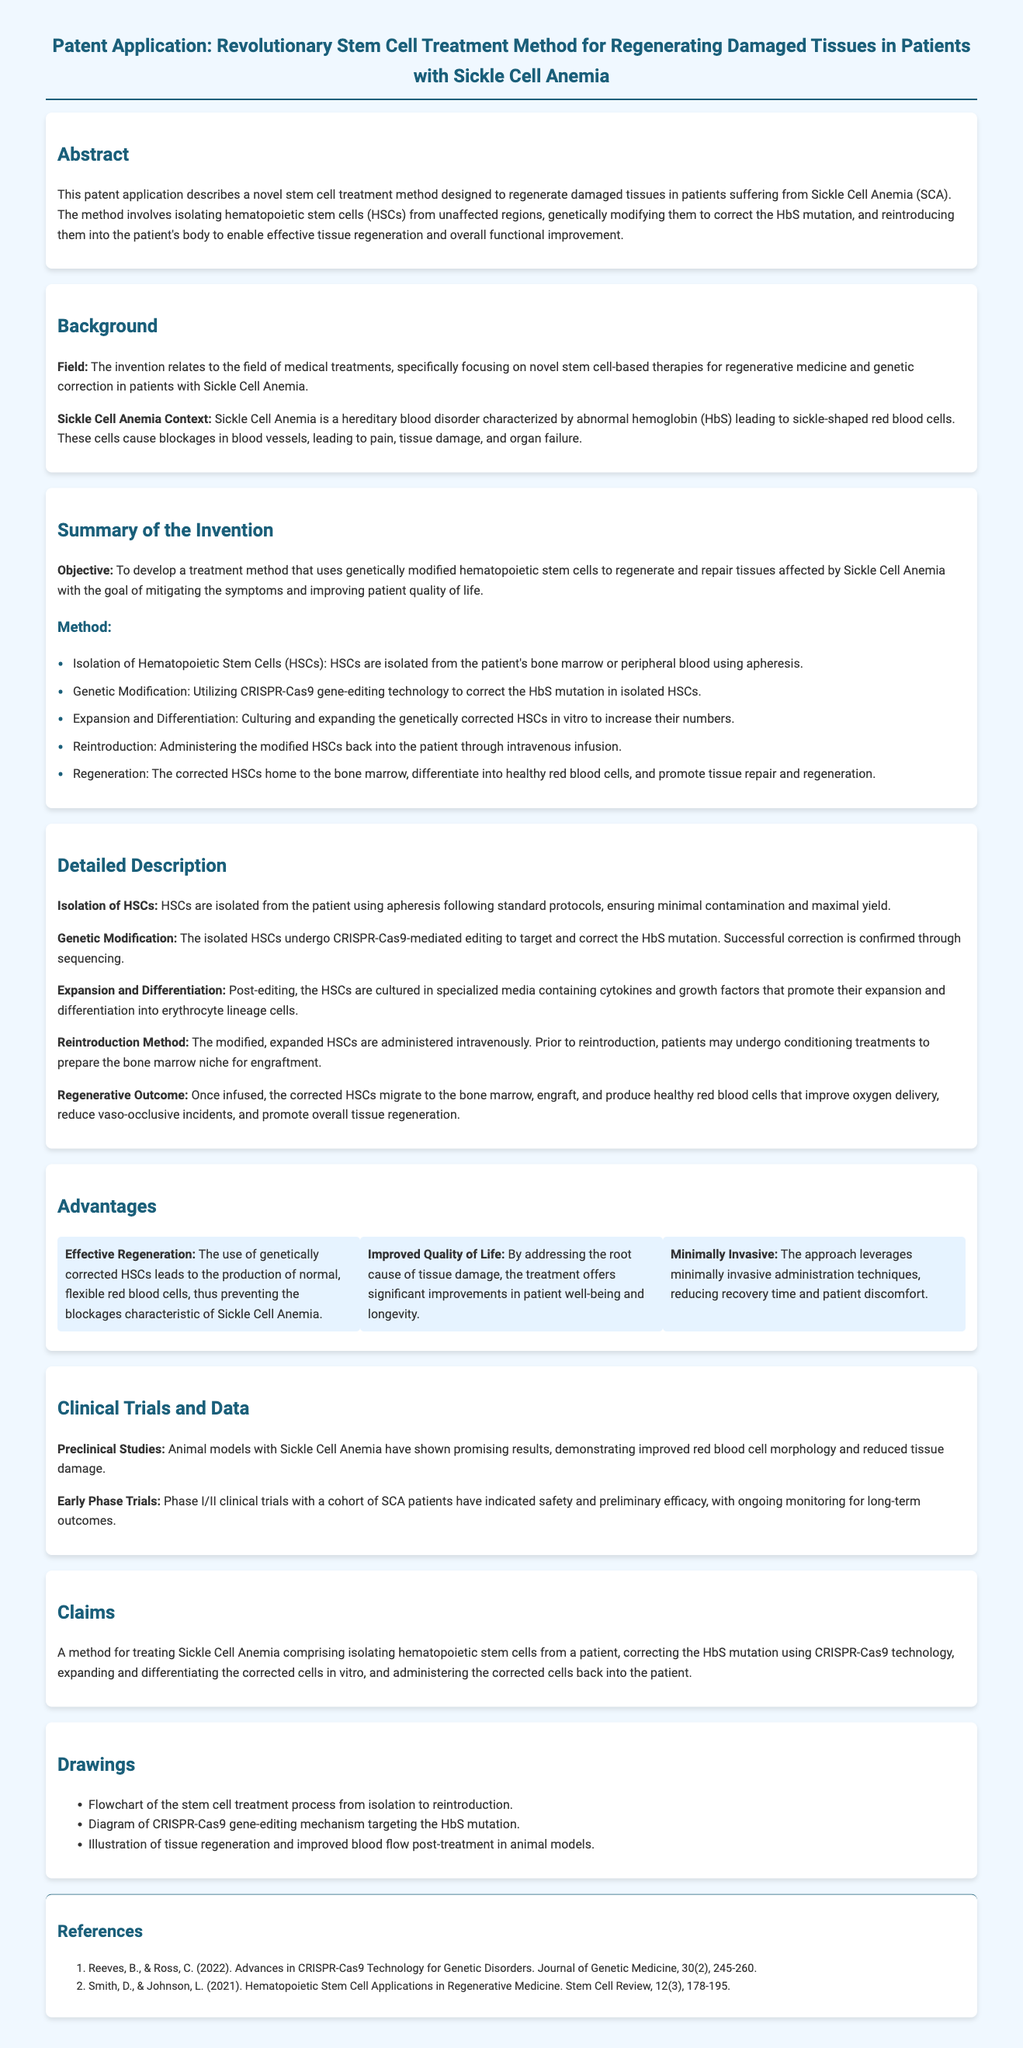What is the primary objective of the treatment method? The primary objective is to develop a treatment method that uses genetically modified hematopoietic stem cells to regenerate and repair tissues affected by Sickle Cell Anemia.
Answer: To develop a treatment method using genetically modified hematopoietic stem cells What technology is used for genetic modification? The technology used for genetic modification in this method is CRISPR-Cas9.
Answer: CRISPR-Cas9 What type of cells are isolated from the patient? The cells that are isolated from the patient are hematopoietic stem cells (HSCs).
Answer: Hematopoietic stem cells (HSCs) What is one major advantage of this treatment? One major advantage mentioned is improved quality of life.
Answer: Improved quality of life How are the corrected stem cells reintroduced into the patient? The corrected stem cells are reintroduced into the patient through intravenous infusion.
Answer: Intravenous infusion What preclinical studies have shown promising results? Animal models with Sickle Cell Anemia have shown promising results.
Answer: Animal models What is a claim made in the patent? A claim made in the patent is a method for treating Sickle Cell Anemia.
Answer: A method for treating Sickle Cell Anemia How many references are cited in the document? There are two references cited in the document.
Answer: Two references What is the purpose of the conditioning treatments before reintroduction? The purpose of the conditioning treatments is to prepare the bone marrow niche for engraftment.
Answer: To prepare the bone marrow niche for engraftment What does the treatment aim to improve in patients? The treatment aims to improve symptoms and patient quality of life.
Answer: Symptoms and patient quality of life 